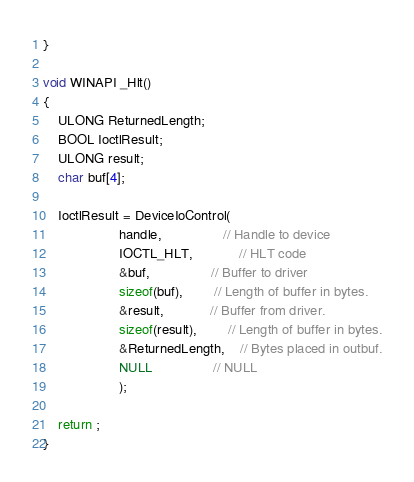<code> <loc_0><loc_0><loc_500><loc_500><_C++_>}

void WINAPI _Hlt()
{
	ULONG ReturnedLength;
 	BOOL IoctlResult;
	ULONG result;
	char buf[4];

	IoctlResult = DeviceIoControl(
					handle,				// Handle to device
					IOCTL_HLT,			// HLT code
					&buf,				// Buffer to driver
					sizeof(buf),		// Length of buffer in bytes.
					&result,			// Buffer from driver.
					sizeof(result),		// Length of buffer in bytes.
					&ReturnedLength,	// Bytes placed in outbuf.
					NULL				// NULL
					);

	return ;
}
</code> 